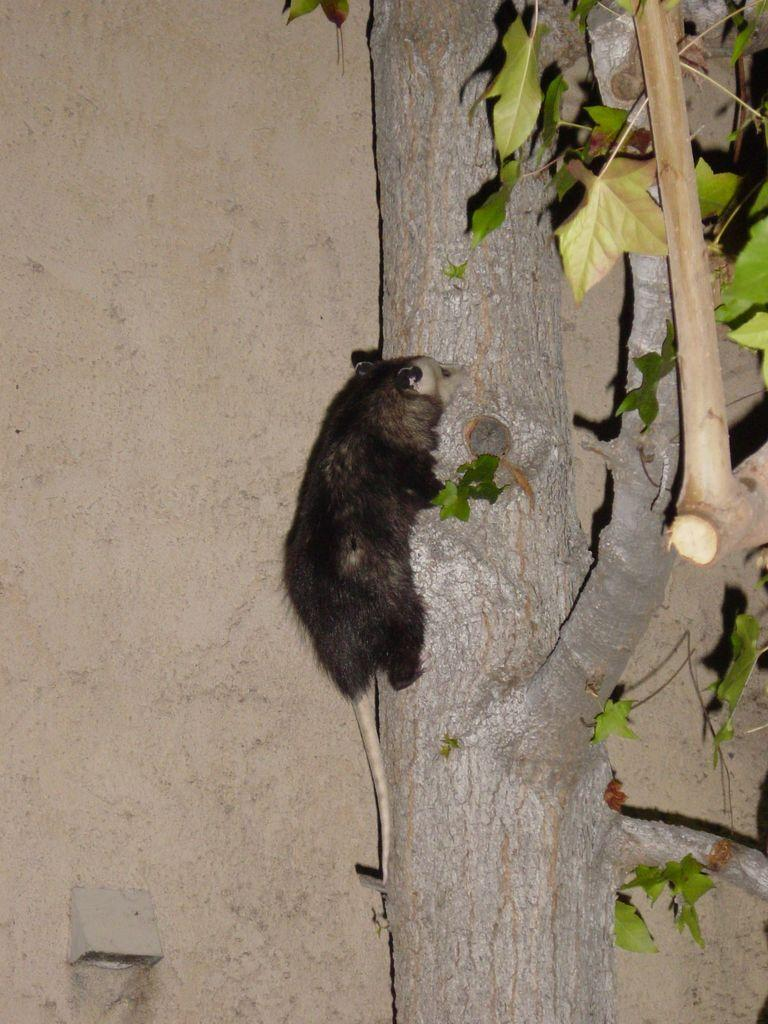What is the main subject of the image? There is an animal in the image. Where is the animal located? The animal is on a tree. What type of garden can be seen surrounding the square in the image? There is no garden or square present in the image; it features an animal on a tree. What advice would the parent give to the child in the image? There is no child or parent present in the image, as it only features an animal on a tree. 